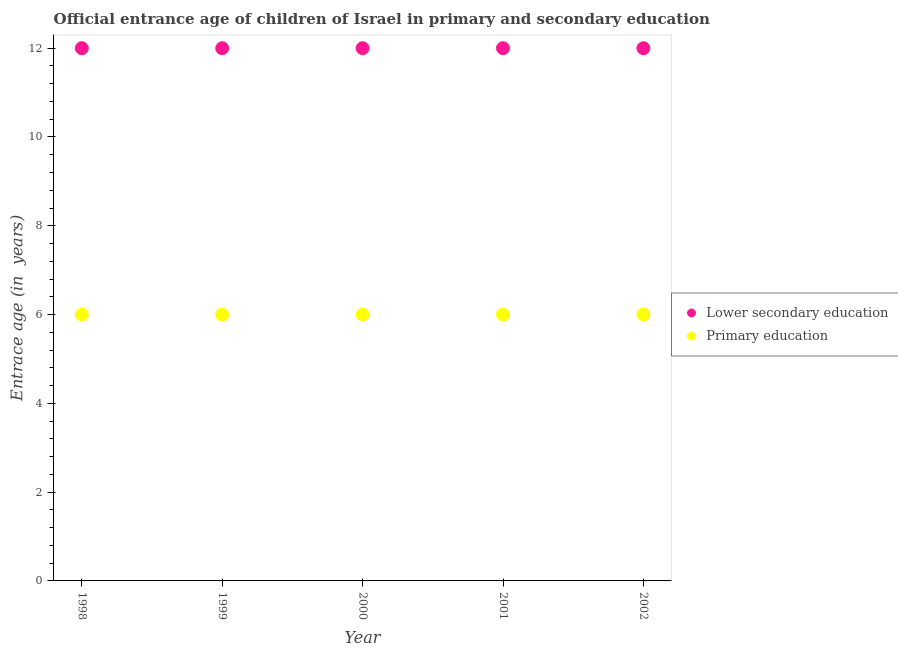How many different coloured dotlines are there?
Offer a very short reply. 2. Is the number of dotlines equal to the number of legend labels?
Your response must be concise. Yes. What is the entrance age of children in lower secondary education in 2001?
Your response must be concise. 12. Across all years, what is the maximum entrance age of children in lower secondary education?
Offer a very short reply. 12. Across all years, what is the minimum entrance age of chiildren in primary education?
Your response must be concise. 6. What is the total entrance age of chiildren in primary education in the graph?
Your response must be concise. 30. What is the difference between the entrance age of children in lower secondary education in 1999 and that in 2000?
Your answer should be compact. 0. What is the difference between the entrance age of children in lower secondary education in 2001 and the entrance age of chiildren in primary education in 2002?
Your response must be concise. 6. What is the average entrance age of children in lower secondary education per year?
Provide a short and direct response. 12. In the year 2001, what is the difference between the entrance age of chiildren in primary education and entrance age of children in lower secondary education?
Ensure brevity in your answer.  -6. In how many years, is the entrance age of chiildren in primary education greater than 11.6 years?
Your response must be concise. 0. What is the ratio of the entrance age of chiildren in primary education in 2000 to that in 2002?
Make the answer very short. 1. How many years are there in the graph?
Give a very brief answer. 5. Does the graph contain grids?
Offer a terse response. No. Where does the legend appear in the graph?
Your answer should be compact. Center right. How are the legend labels stacked?
Give a very brief answer. Vertical. What is the title of the graph?
Your answer should be compact. Official entrance age of children of Israel in primary and secondary education. Does "Gasoline" appear as one of the legend labels in the graph?
Your response must be concise. No. What is the label or title of the X-axis?
Your response must be concise. Year. What is the label or title of the Y-axis?
Your response must be concise. Entrace age (in  years). What is the Entrace age (in  years) in Lower secondary education in 1998?
Provide a succinct answer. 12. What is the Entrace age (in  years) of Primary education in 2000?
Your response must be concise. 6. What is the Entrace age (in  years) in Primary education in 2001?
Keep it short and to the point. 6. Across all years, what is the maximum Entrace age (in  years) of Primary education?
Your response must be concise. 6. Across all years, what is the minimum Entrace age (in  years) in Primary education?
Ensure brevity in your answer.  6. What is the difference between the Entrace age (in  years) in Primary education in 1998 and that in 1999?
Keep it short and to the point. 0. What is the difference between the Entrace age (in  years) in Lower secondary education in 1998 and that in 2002?
Give a very brief answer. 0. What is the difference between the Entrace age (in  years) in Lower secondary education in 1999 and that in 2000?
Your answer should be compact. 0. What is the difference between the Entrace age (in  years) in Primary education in 1999 and that in 2000?
Your answer should be compact. 0. What is the difference between the Entrace age (in  years) in Lower secondary education in 1999 and that in 2001?
Your answer should be very brief. 0. What is the difference between the Entrace age (in  years) in Primary education in 1999 and that in 2002?
Offer a very short reply. 0. What is the difference between the Entrace age (in  years) of Primary education in 2000 and that in 2002?
Keep it short and to the point. 0. What is the difference between the Entrace age (in  years) in Lower secondary education in 2001 and that in 2002?
Give a very brief answer. 0. What is the difference between the Entrace age (in  years) of Lower secondary education in 1998 and the Entrace age (in  years) of Primary education in 1999?
Provide a succinct answer. 6. What is the difference between the Entrace age (in  years) in Lower secondary education in 1998 and the Entrace age (in  years) in Primary education in 2000?
Ensure brevity in your answer.  6. What is the difference between the Entrace age (in  years) in Lower secondary education in 1998 and the Entrace age (in  years) in Primary education in 2001?
Provide a short and direct response. 6. What is the difference between the Entrace age (in  years) in Lower secondary education in 1999 and the Entrace age (in  years) in Primary education in 2001?
Offer a very short reply. 6. What is the difference between the Entrace age (in  years) in Lower secondary education in 2001 and the Entrace age (in  years) in Primary education in 2002?
Offer a terse response. 6. In the year 1999, what is the difference between the Entrace age (in  years) in Lower secondary education and Entrace age (in  years) in Primary education?
Provide a short and direct response. 6. In the year 2000, what is the difference between the Entrace age (in  years) of Lower secondary education and Entrace age (in  years) of Primary education?
Your response must be concise. 6. In the year 2001, what is the difference between the Entrace age (in  years) of Lower secondary education and Entrace age (in  years) of Primary education?
Your response must be concise. 6. In the year 2002, what is the difference between the Entrace age (in  years) in Lower secondary education and Entrace age (in  years) in Primary education?
Your answer should be compact. 6. What is the ratio of the Entrace age (in  years) of Primary education in 1998 to that in 1999?
Give a very brief answer. 1. What is the ratio of the Entrace age (in  years) of Lower secondary education in 1998 to that in 2000?
Provide a short and direct response. 1. What is the ratio of the Entrace age (in  years) in Lower secondary education in 1998 to that in 2001?
Offer a terse response. 1. What is the ratio of the Entrace age (in  years) in Primary education in 1998 to that in 2001?
Your answer should be compact. 1. What is the ratio of the Entrace age (in  years) in Lower secondary education in 1998 to that in 2002?
Give a very brief answer. 1. What is the ratio of the Entrace age (in  years) in Primary education in 1998 to that in 2002?
Provide a short and direct response. 1. What is the ratio of the Entrace age (in  years) in Primary education in 1999 to that in 2000?
Your response must be concise. 1. What is the ratio of the Entrace age (in  years) of Lower secondary education in 1999 to that in 2001?
Give a very brief answer. 1. What is the ratio of the Entrace age (in  years) of Primary education in 1999 to that in 2002?
Give a very brief answer. 1. What is the ratio of the Entrace age (in  years) of Lower secondary education in 2000 to that in 2001?
Your answer should be very brief. 1. What is the ratio of the Entrace age (in  years) in Primary education in 2000 to that in 2001?
Make the answer very short. 1. What is the ratio of the Entrace age (in  years) in Lower secondary education in 2000 to that in 2002?
Offer a very short reply. 1. What is the difference between the highest and the second highest Entrace age (in  years) in Lower secondary education?
Your response must be concise. 0. What is the difference between the highest and the lowest Entrace age (in  years) in Lower secondary education?
Give a very brief answer. 0. What is the difference between the highest and the lowest Entrace age (in  years) in Primary education?
Keep it short and to the point. 0. 